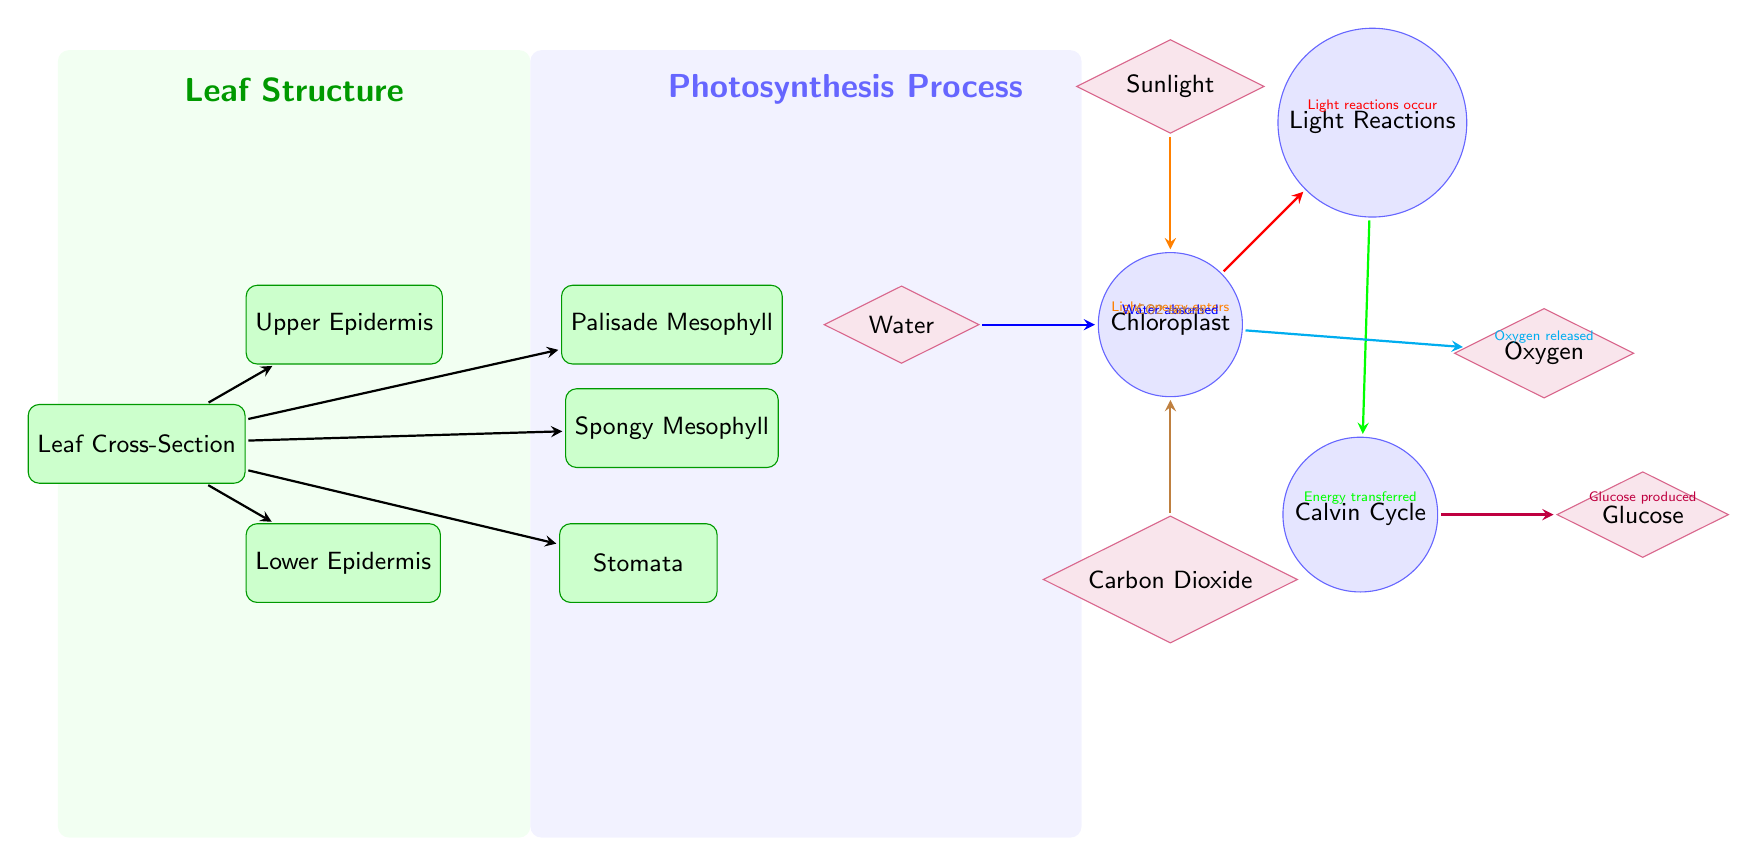What is the main process depicted in the diagram? The diagram illustrates the process of photosynthesis, emphasizing the various steps and components involved.
Answer: Photosynthesis How many types of leaf parts are labeled in the diagram? The diagram shows five types of leaf parts: Upper Epidermis, Palisade Mesophyll, Spongy Mesophyll, Lower Epidermis, and Stomata. Counting these parts gives us a total of five.
Answer: 5 Which molecule is indicated as the source of energy? The diagram shows the Sunlight as the source of energy that enters the chloroplast, which is pivotal for the photosynthesis process.
Answer: Sunlight What is produced during the Calvin cycle? The Calvin cycle in the diagram results in the production of Glucose, which is a key output of photosynthesis.
Answer: Glucose What enters the chloroplast from the stomata? The diagram indicates that Carbon Dioxide enters the chloroplast from the stomata, highlighting its role in the photosynthetic process.
Answer: CO2 Explain the flow of energy from sunlight to glucose production. The sunlight enters the chloroplast, where light reactions occur (indicated by the right arrow). During these reactions, energy is transferred to the Calvin cycle, which then leads to the production of glucose. This sequence shows the essential role of sunlight in creating glucose through photosynthesis.
Answer: Energy flow: Sunlight → Chloroplast → Light reactions → Calvin Cycle → Glucose What is released as a byproduct of photosynthesis? According to the diagram, Oxygen is released from the chloroplast as a byproduct of photosynthesis once the light reactions have taken place.
Answer: Oxygen In which part of the leaf does most photosynthesis occur? The diagram indicates that the major site of photosynthesis within the leaf is the Palisade Mesophyll, where chloroplasts are abundant.
Answer: Palisade Mesophyll How does water enter the chloroplast as described in the diagram? Water is shown to be absorbed, indicating its movement from outside the leaf into the chloroplast for use in the photosynthesis process.
Answer: Water absorbed 